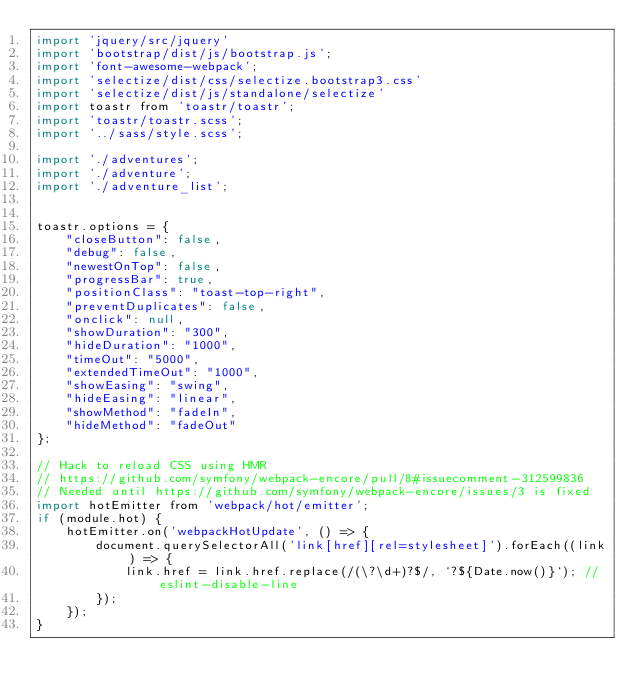Convert code to text. <code><loc_0><loc_0><loc_500><loc_500><_JavaScript_>import 'jquery/src/jquery'
import 'bootstrap/dist/js/bootstrap.js';
import 'font-awesome-webpack';
import 'selectize/dist/css/selectize.bootstrap3.css'
import 'selectize/dist/js/standalone/selectize'
import toastr from 'toastr/toastr';
import 'toastr/toastr.scss';
import '../sass/style.scss';

import './adventures';
import './adventure';
import './adventure_list';


toastr.options = {
    "closeButton": false,
    "debug": false,
    "newestOnTop": false,
    "progressBar": true,
    "positionClass": "toast-top-right",
    "preventDuplicates": false,
    "onclick": null,
    "showDuration": "300",
    "hideDuration": "1000",
    "timeOut": "5000",
    "extendedTimeOut": "1000",
    "showEasing": "swing",
    "hideEasing": "linear",
    "showMethod": "fadeIn",
    "hideMethod": "fadeOut"
};

// Hack to reload CSS using HMR
// https://github.com/symfony/webpack-encore/pull/8#issuecomment-312599836
// Needed until https://github.com/symfony/webpack-encore/issues/3 is fixed
import hotEmitter from 'webpack/hot/emitter';
if (module.hot) {
    hotEmitter.on('webpackHotUpdate', () => {
        document.querySelectorAll('link[href][rel=stylesheet]').forEach((link) => {
            link.href = link.href.replace(/(\?\d+)?$/, `?${Date.now()}`); // eslint-disable-line
        });
    });
}
</code> 